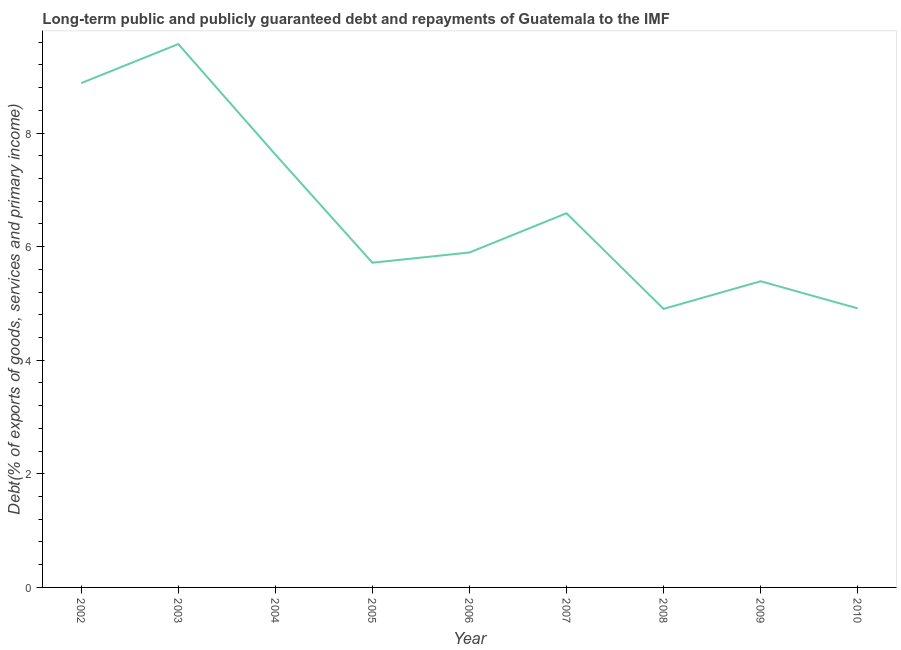What is the debt service in 2007?
Keep it short and to the point. 6.59. Across all years, what is the maximum debt service?
Ensure brevity in your answer.  9.57. Across all years, what is the minimum debt service?
Your answer should be very brief. 4.9. In which year was the debt service minimum?
Your answer should be compact. 2008. What is the sum of the debt service?
Offer a very short reply. 59.48. What is the difference between the debt service in 2002 and 2009?
Ensure brevity in your answer.  3.49. What is the average debt service per year?
Give a very brief answer. 6.61. What is the median debt service?
Keep it short and to the point. 5.9. In how many years, is the debt service greater than 1.2000000000000002 %?
Your response must be concise. 9. Do a majority of the years between 2006 and 2002 (inclusive) have debt service greater than 0.4 %?
Your answer should be compact. Yes. What is the ratio of the debt service in 2006 to that in 2009?
Your answer should be compact. 1.09. What is the difference between the highest and the second highest debt service?
Ensure brevity in your answer.  0.69. What is the difference between the highest and the lowest debt service?
Provide a succinct answer. 4.66. What is the difference between two consecutive major ticks on the Y-axis?
Give a very brief answer. 2. Does the graph contain any zero values?
Provide a short and direct response. No. What is the title of the graph?
Make the answer very short. Long-term public and publicly guaranteed debt and repayments of Guatemala to the IMF. What is the label or title of the Y-axis?
Your answer should be compact. Debt(% of exports of goods, services and primary income). What is the Debt(% of exports of goods, services and primary income) in 2002?
Your answer should be very brief. 8.88. What is the Debt(% of exports of goods, services and primary income) in 2003?
Make the answer very short. 9.57. What is the Debt(% of exports of goods, services and primary income) of 2004?
Make the answer very short. 7.62. What is the Debt(% of exports of goods, services and primary income) in 2005?
Give a very brief answer. 5.72. What is the Debt(% of exports of goods, services and primary income) in 2006?
Your answer should be very brief. 5.9. What is the Debt(% of exports of goods, services and primary income) in 2007?
Make the answer very short. 6.59. What is the Debt(% of exports of goods, services and primary income) of 2008?
Give a very brief answer. 4.9. What is the Debt(% of exports of goods, services and primary income) of 2009?
Ensure brevity in your answer.  5.39. What is the Debt(% of exports of goods, services and primary income) of 2010?
Provide a succinct answer. 4.91. What is the difference between the Debt(% of exports of goods, services and primary income) in 2002 and 2003?
Give a very brief answer. -0.69. What is the difference between the Debt(% of exports of goods, services and primary income) in 2002 and 2004?
Make the answer very short. 1.26. What is the difference between the Debt(% of exports of goods, services and primary income) in 2002 and 2005?
Offer a terse response. 3.16. What is the difference between the Debt(% of exports of goods, services and primary income) in 2002 and 2006?
Offer a very short reply. 2.98. What is the difference between the Debt(% of exports of goods, services and primary income) in 2002 and 2007?
Keep it short and to the point. 2.29. What is the difference between the Debt(% of exports of goods, services and primary income) in 2002 and 2008?
Give a very brief answer. 3.98. What is the difference between the Debt(% of exports of goods, services and primary income) in 2002 and 2009?
Your answer should be compact. 3.49. What is the difference between the Debt(% of exports of goods, services and primary income) in 2002 and 2010?
Ensure brevity in your answer.  3.97. What is the difference between the Debt(% of exports of goods, services and primary income) in 2003 and 2004?
Provide a short and direct response. 1.94. What is the difference between the Debt(% of exports of goods, services and primary income) in 2003 and 2005?
Make the answer very short. 3.85. What is the difference between the Debt(% of exports of goods, services and primary income) in 2003 and 2006?
Your answer should be very brief. 3.67. What is the difference between the Debt(% of exports of goods, services and primary income) in 2003 and 2007?
Your answer should be very brief. 2.98. What is the difference between the Debt(% of exports of goods, services and primary income) in 2003 and 2008?
Keep it short and to the point. 4.66. What is the difference between the Debt(% of exports of goods, services and primary income) in 2003 and 2009?
Your answer should be compact. 4.18. What is the difference between the Debt(% of exports of goods, services and primary income) in 2003 and 2010?
Keep it short and to the point. 4.65. What is the difference between the Debt(% of exports of goods, services and primary income) in 2004 and 2005?
Give a very brief answer. 1.91. What is the difference between the Debt(% of exports of goods, services and primary income) in 2004 and 2006?
Your answer should be compact. 1.73. What is the difference between the Debt(% of exports of goods, services and primary income) in 2004 and 2007?
Provide a succinct answer. 1.03. What is the difference between the Debt(% of exports of goods, services and primary income) in 2004 and 2008?
Provide a succinct answer. 2.72. What is the difference between the Debt(% of exports of goods, services and primary income) in 2004 and 2009?
Offer a terse response. 2.23. What is the difference between the Debt(% of exports of goods, services and primary income) in 2004 and 2010?
Make the answer very short. 2.71. What is the difference between the Debt(% of exports of goods, services and primary income) in 2005 and 2006?
Offer a terse response. -0.18. What is the difference between the Debt(% of exports of goods, services and primary income) in 2005 and 2007?
Give a very brief answer. -0.87. What is the difference between the Debt(% of exports of goods, services and primary income) in 2005 and 2008?
Offer a terse response. 0.81. What is the difference between the Debt(% of exports of goods, services and primary income) in 2005 and 2009?
Keep it short and to the point. 0.33. What is the difference between the Debt(% of exports of goods, services and primary income) in 2005 and 2010?
Offer a very short reply. 0.8. What is the difference between the Debt(% of exports of goods, services and primary income) in 2006 and 2007?
Offer a very short reply. -0.69. What is the difference between the Debt(% of exports of goods, services and primary income) in 2006 and 2008?
Your answer should be very brief. 0.99. What is the difference between the Debt(% of exports of goods, services and primary income) in 2006 and 2009?
Provide a succinct answer. 0.51. What is the difference between the Debt(% of exports of goods, services and primary income) in 2006 and 2010?
Keep it short and to the point. 0.98. What is the difference between the Debt(% of exports of goods, services and primary income) in 2007 and 2008?
Provide a short and direct response. 1.68. What is the difference between the Debt(% of exports of goods, services and primary income) in 2007 and 2009?
Give a very brief answer. 1.2. What is the difference between the Debt(% of exports of goods, services and primary income) in 2007 and 2010?
Offer a terse response. 1.68. What is the difference between the Debt(% of exports of goods, services and primary income) in 2008 and 2009?
Your answer should be compact. -0.49. What is the difference between the Debt(% of exports of goods, services and primary income) in 2008 and 2010?
Give a very brief answer. -0.01. What is the difference between the Debt(% of exports of goods, services and primary income) in 2009 and 2010?
Ensure brevity in your answer.  0.48. What is the ratio of the Debt(% of exports of goods, services and primary income) in 2002 to that in 2003?
Keep it short and to the point. 0.93. What is the ratio of the Debt(% of exports of goods, services and primary income) in 2002 to that in 2004?
Keep it short and to the point. 1.17. What is the ratio of the Debt(% of exports of goods, services and primary income) in 2002 to that in 2005?
Offer a very short reply. 1.55. What is the ratio of the Debt(% of exports of goods, services and primary income) in 2002 to that in 2006?
Your answer should be compact. 1.51. What is the ratio of the Debt(% of exports of goods, services and primary income) in 2002 to that in 2007?
Give a very brief answer. 1.35. What is the ratio of the Debt(% of exports of goods, services and primary income) in 2002 to that in 2008?
Offer a terse response. 1.81. What is the ratio of the Debt(% of exports of goods, services and primary income) in 2002 to that in 2009?
Offer a terse response. 1.65. What is the ratio of the Debt(% of exports of goods, services and primary income) in 2002 to that in 2010?
Offer a terse response. 1.81. What is the ratio of the Debt(% of exports of goods, services and primary income) in 2003 to that in 2004?
Offer a terse response. 1.25. What is the ratio of the Debt(% of exports of goods, services and primary income) in 2003 to that in 2005?
Offer a terse response. 1.67. What is the ratio of the Debt(% of exports of goods, services and primary income) in 2003 to that in 2006?
Ensure brevity in your answer.  1.62. What is the ratio of the Debt(% of exports of goods, services and primary income) in 2003 to that in 2007?
Give a very brief answer. 1.45. What is the ratio of the Debt(% of exports of goods, services and primary income) in 2003 to that in 2008?
Offer a very short reply. 1.95. What is the ratio of the Debt(% of exports of goods, services and primary income) in 2003 to that in 2009?
Make the answer very short. 1.77. What is the ratio of the Debt(% of exports of goods, services and primary income) in 2003 to that in 2010?
Keep it short and to the point. 1.95. What is the ratio of the Debt(% of exports of goods, services and primary income) in 2004 to that in 2005?
Your response must be concise. 1.33. What is the ratio of the Debt(% of exports of goods, services and primary income) in 2004 to that in 2006?
Offer a terse response. 1.29. What is the ratio of the Debt(% of exports of goods, services and primary income) in 2004 to that in 2007?
Your response must be concise. 1.16. What is the ratio of the Debt(% of exports of goods, services and primary income) in 2004 to that in 2008?
Your response must be concise. 1.55. What is the ratio of the Debt(% of exports of goods, services and primary income) in 2004 to that in 2009?
Your response must be concise. 1.41. What is the ratio of the Debt(% of exports of goods, services and primary income) in 2004 to that in 2010?
Offer a terse response. 1.55. What is the ratio of the Debt(% of exports of goods, services and primary income) in 2005 to that in 2006?
Your answer should be compact. 0.97. What is the ratio of the Debt(% of exports of goods, services and primary income) in 2005 to that in 2007?
Keep it short and to the point. 0.87. What is the ratio of the Debt(% of exports of goods, services and primary income) in 2005 to that in 2008?
Your answer should be compact. 1.17. What is the ratio of the Debt(% of exports of goods, services and primary income) in 2005 to that in 2009?
Make the answer very short. 1.06. What is the ratio of the Debt(% of exports of goods, services and primary income) in 2005 to that in 2010?
Offer a terse response. 1.16. What is the ratio of the Debt(% of exports of goods, services and primary income) in 2006 to that in 2007?
Offer a very short reply. 0.9. What is the ratio of the Debt(% of exports of goods, services and primary income) in 2006 to that in 2008?
Provide a succinct answer. 1.2. What is the ratio of the Debt(% of exports of goods, services and primary income) in 2006 to that in 2009?
Keep it short and to the point. 1.09. What is the ratio of the Debt(% of exports of goods, services and primary income) in 2007 to that in 2008?
Your response must be concise. 1.34. What is the ratio of the Debt(% of exports of goods, services and primary income) in 2007 to that in 2009?
Provide a short and direct response. 1.22. What is the ratio of the Debt(% of exports of goods, services and primary income) in 2007 to that in 2010?
Offer a terse response. 1.34. What is the ratio of the Debt(% of exports of goods, services and primary income) in 2008 to that in 2009?
Keep it short and to the point. 0.91. What is the ratio of the Debt(% of exports of goods, services and primary income) in 2009 to that in 2010?
Provide a short and direct response. 1.1. 